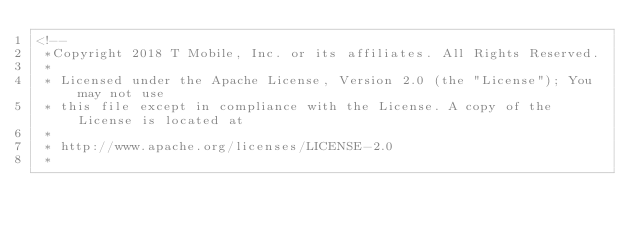<code> <loc_0><loc_0><loc_500><loc_500><_HTML_><!--
 *Copyright 2018 T Mobile, Inc. or its affiliates. All Rights Reserved.
 *
 * Licensed under the Apache License, Version 2.0 (the "License"); You may not use
 * this file except in compliance with the License. A copy of the License is located at
 * 
 * http://www.apache.org/licenses/LICENSE-2.0
 * </code> 